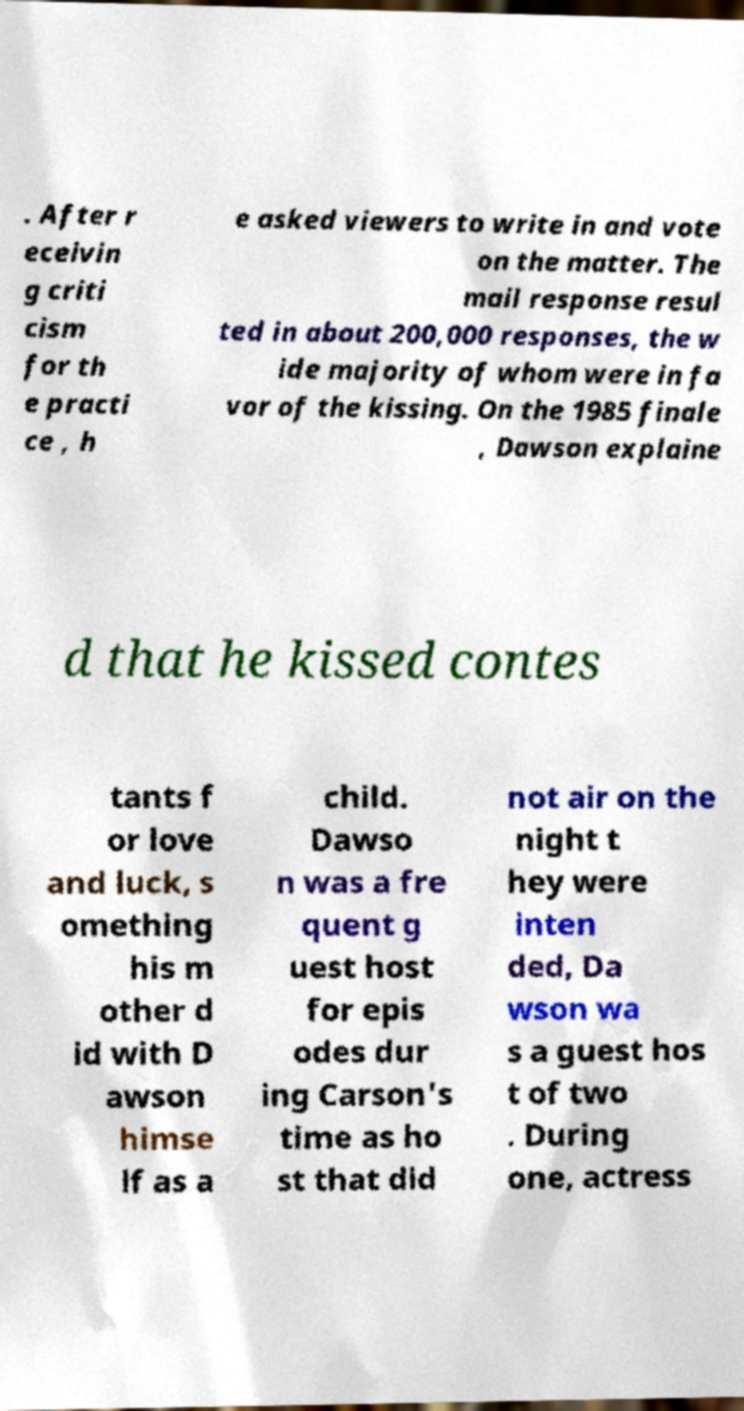What messages or text are displayed in this image? I need them in a readable, typed format. . After r eceivin g criti cism for th e practi ce , h e asked viewers to write in and vote on the matter. The mail response resul ted in about 200,000 responses, the w ide majority of whom were in fa vor of the kissing. On the 1985 finale , Dawson explaine d that he kissed contes tants f or love and luck, s omething his m other d id with D awson himse lf as a child. Dawso n was a fre quent g uest host for epis odes dur ing Carson's time as ho st that did not air on the night t hey were inten ded, Da wson wa s a guest hos t of two . During one, actress 